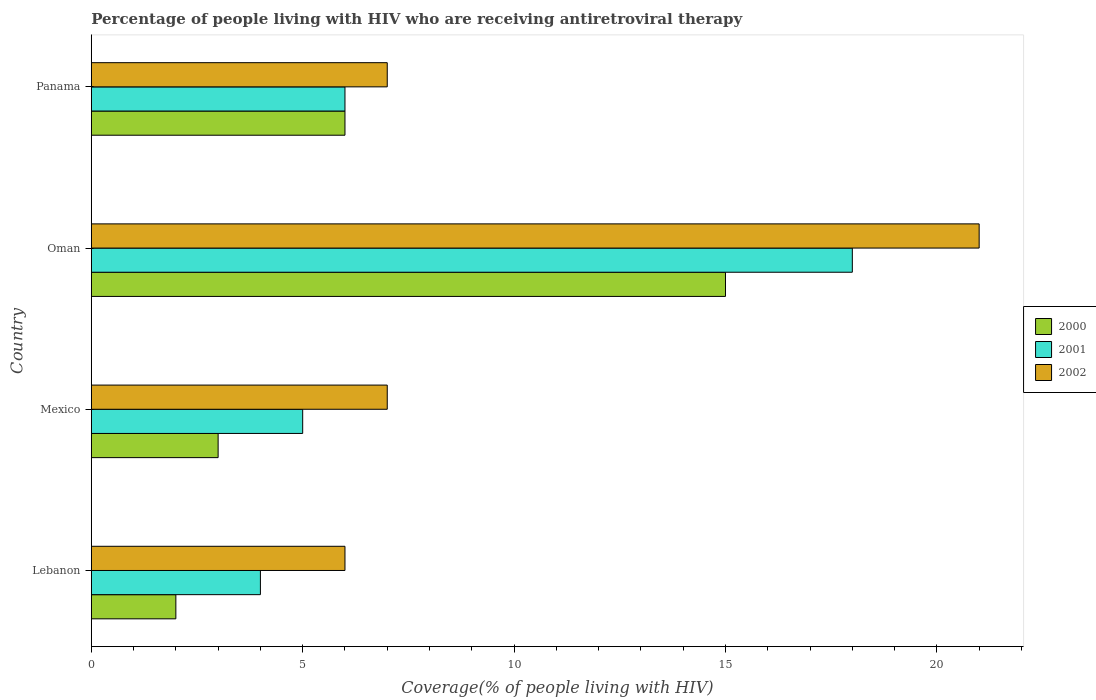How many different coloured bars are there?
Offer a terse response. 3. Are the number of bars per tick equal to the number of legend labels?
Your answer should be compact. Yes. Are the number of bars on each tick of the Y-axis equal?
Your answer should be compact. Yes. How many bars are there on the 3rd tick from the top?
Ensure brevity in your answer.  3. What is the label of the 3rd group of bars from the top?
Provide a succinct answer. Mexico. In how many cases, is the number of bars for a given country not equal to the number of legend labels?
Provide a succinct answer. 0. Across all countries, what is the minimum percentage of the HIV infected people who are receiving antiretroviral therapy in 2000?
Offer a very short reply. 2. In which country was the percentage of the HIV infected people who are receiving antiretroviral therapy in 2002 maximum?
Your answer should be compact. Oman. In which country was the percentage of the HIV infected people who are receiving antiretroviral therapy in 2001 minimum?
Offer a terse response. Lebanon. What is the average percentage of the HIV infected people who are receiving antiretroviral therapy in 2002 per country?
Keep it short and to the point. 10.25. In how many countries, is the percentage of the HIV infected people who are receiving antiretroviral therapy in 2000 greater than 5 %?
Make the answer very short. 2. What is the ratio of the percentage of the HIV infected people who are receiving antiretroviral therapy in 2002 in Lebanon to that in Panama?
Offer a terse response. 0.86. Is the percentage of the HIV infected people who are receiving antiretroviral therapy in 2002 in Lebanon less than that in Oman?
Give a very brief answer. Yes. Is the difference between the percentage of the HIV infected people who are receiving antiretroviral therapy in 2002 in Mexico and Oman greater than the difference between the percentage of the HIV infected people who are receiving antiretroviral therapy in 2001 in Mexico and Oman?
Provide a succinct answer. No. What is the difference between the highest and the second highest percentage of the HIV infected people who are receiving antiretroviral therapy in 2001?
Offer a very short reply. 12. What is the difference between the highest and the lowest percentage of the HIV infected people who are receiving antiretroviral therapy in 2002?
Your answer should be compact. 15. In how many countries, is the percentage of the HIV infected people who are receiving antiretroviral therapy in 2001 greater than the average percentage of the HIV infected people who are receiving antiretroviral therapy in 2001 taken over all countries?
Offer a very short reply. 1. Is the sum of the percentage of the HIV infected people who are receiving antiretroviral therapy in 2000 in Mexico and Panama greater than the maximum percentage of the HIV infected people who are receiving antiretroviral therapy in 2001 across all countries?
Offer a very short reply. No. What does the 1st bar from the bottom in Mexico represents?
Ensure brevity in your answer.  2000. Is it the case that in every country, the sum of the percentage of the HIV infected people who are receiving antiretroviral therapy in 2000 and percentage of the HIV infected people who are receiving antiretroviral therapy in 2002 is greater than the percentage of the HIV infected people who are receiving antiretroviral therapy in 2001?
Offer a terse response. Yes. Are all the bars in the graph horizontal?
Give a very brief answer. Yes. How many countries are there in the graph?
Keep it short and to the point. 4. What is the difference between two consecutive major ticks on the X-axis?
Provide a short and direct response. 5. Does the graph contain grids?
Offer a very short reply. No. How many legend labels are there?
Provide a short and direct response. 3. How are the legend labels stacked?
Provide a short and direct response. Vertical. What is the title of the graph?
Ensure brevity in your answer.  Percentage of people living with HIV who are receiving antiretroviral therapy. Does "1962" appear as one of the legend labels in the graph?
Ensure brevity in your answer.  No. What is the label or title of the X-axis?
Provide a short and direct response. Coverage(% of people living with HIV). What is the Coverage(% of people living with HIV) of 2000 in Lebanon?
Provide a succinct answer. 2. What is the Coverage(% of people living with HIV) of 2001 in Lebanon?
Keep it short and to the point. 4. What is the Coverage(% of people living with HIV) of 2002 in Lebanon?
Provide a short and direct response. 6. What is the Coverage(% of people living with HIV) in 2000 in Mexico?
Offer a terse response. 3. What is the Coverage(% of people living with HIV) of 2000 in Oman?
Provide a succinct answer. 15. What is the Coverage(% of people living with HIV) in 2002 in Oman?
Offer a very short reply. 21. What is the Coverage(% of people living with HIV) of 2000 in Panama?
Provide a succinct answer. 6. Across all countries, what is the maximum Coverage(% of people living with HIV) of 2000?
Provide a succinct answer. 15. Across all countries, what is the minimum Coverage(% of people living with HIV) in 2000?
Your answer should be compact. 2. Across all countries, what is the minimum Coverage(% of people living with HIV) of 2001?
Keep it short and to the point. 4. What is the total Coverage(% of people living with HIV) in 2000 in the graph?
Offer a very short reply. 26. What is the total Coverage(% of people living with HIV) in 2001 in the graph?
Offer a very short reply. 33. What is the total Coverage(% of people living with HIV) in 2002 in the graph?
Provide a succinct answer. 41. What is the difference between the Coverage(% of people living with HIV) of 2001 in Lebanon and that in Mexico?
Offer a terse response. -1. What is the difference between the Coverage(% of people living with HIV) of 2000 in Lebanon and that in Oman?
Offer a terse response. -13. What is the difference between the Coverage(% of people living with HIV) of 2001 in Lebanon and that in Oman?
Your response must be concise. -14. What is the difference between the Coverage(% of people living with HIV) in 2001 in Lebanon and that in Panama?
Provide a succinct answer. -2. What is the difference between the Coverage(% of people living with HIV) in 2002 in Lebanon and that in Panama?
Provide a short and direct response. -1. What is the difference between the Coverage(% of people living with HIV) in 2000 in Mexico and that in Panama?
Give a very brief answer. -3. What is the difference between the Coverage(% of people living with HIV) of 2001 in Mexico and that in Panama?
Ensure brevity in your answer.  -1. What is the difference between the Coverage(% of people living with HIV) of 2002 in Mexico and that in Panama?
Your response must be concise. 0. What is the difference between the Coverage(% of people living with HIV) in 2002 in Oman and that in Panama?
Offer a terse response. 14. What is the difference between the Coverage(% of people living with HIV) of 2001 in Lebanon and the Coverage(% of people living with HIV) of 2002 in Mexico?
Keep it short and to the point. -3. What is the difference between the Coverage(% of people living with HIV) of 2000 in Lebanon and the Coverage(% of people living with HIV) of 2002 in Oman?
Offer a terse response. -19. What is the difference between the Coverage(% of people living with HIV) in 2001 in Lebanon and the Coverage(% of people living with HIV) in 2002 in Panama?
Keep it short and to the point. -3. What is the difference between the Coverage(% of people living with HIV) in 2000 in Mexico and the Coverage(% of people living with HIV) in 2001 in Panama?
Ensure brevity in your answer.  -3. What is the difference between the Coverage(% of people living with HIV) of 2000 in Mexico and the Coverage(% of people living with HIV) of 2002 in Panama?
Give a very brief answer. -4. What is the difference between the Coverage(% of people living with HIV) of 2000 in Oman and the Coverage(% of people living with HIV) of 2001 in Panama?
Your answer should be very brief. 9. What is the difference between the Coverage(% of people living with HIV) of 2000 in Oman and the Coverage(% of people living with HIV) of 2002 in Panama?
Provide a short and direct response. 8. What is the average Coverage(% of people living with HIV) of 2000 per country?
Ensure brevity in your answer.  6.5. What is the average Coverage(% of people living with HIV) of 2001 per country?
Your answer should be compact. 8.25. What is the average Coverage(% of people living with HIV) of 2002 per country?
Give a very brief answer. 10.25. What is the difference between the Coverage(% of people living with HIV) of 2000 and Coverage(% of people living with HIV) of 2001 in Lebanon?
Ensure brevity in your answer.  -2. What is the difference between the Coverage(% of people living with HIV) in 2000 and Coverage(% of people living with HIV) in 2002 in Lebanon?
Offer a terse response. -4. What is the difference between the Coverage(% of people living with HIV) in 2001 and Coverage(% of people living with HIV) in 2002 in Lebanon?
Offer a terse response. -2. What is the difference between the Coverage(% of people living with HIV) of 2001 and Coverage(% of people living with HIV) of 2002 in Mexico?
Offer a terse response. -2. What is the difference between the Coverage(% of people living with HIV) in 2000 and Coverage(% of people living with HIV) in 2002 in Oman?
Keep it short and to the point. -6. What is the difference between the Coverage(% of people living with HIV) in 2000 and Coverage(% of people living with HIV) in 2002 in Panama?
Provide a short and direct response. -1. What is the difference between the Coverage(% of people living with HIV) of 2001 and Coverage(% of people living with HIV) of 2002 in Panama?
Give a very brief answer. -1. What is the ratio of the Coverage(% of people living with HIV) in 2002 in Lebanon to that in Mexico?
Offer a very short reply. 0.86. What is the ratio of the Coverage(% of people living with HIV) in 2000 in Lebanon to that in Oman?
Give a very brief answer. 0.13. What is the ratio of the Coverage(% of people living with HIV) of 2001 in Lebanon to that in Oman?
Keep it short and to the point. 0.22. What is the ratio of the Coverage(% of people living with HIV) of 2002 in Lebanon to that in Oman?
Provide a short and direct response. 0.29. What is the ratio of the Coverage(% of people living with HIV) in 2000 in Lebanon to that in Panama?
Provide a short and direct response. 0.33. What is the ratio of the Coverage(% of people living with HIV) in 2002 in Lebanon to that in Panama?
Provide a short and direct response. 0.86. What is the ratio of the Coverage(% of people living with HIV) in 2001 in Mexico to that in Oman?
Your answer should be compact. 0.28. What is the ratio of the Coverage(% of people living with HIV) of 2001 in Mexico to that in Panama?
Give a very brief answer. 0.83. What is the ratio of the Coverage(% of people living with HIV) in 2000 in Oman to that in Panama?
Your response must be concise. 2.5. What is the ratio of the Coverage(% of people living with HIV) of 2002 in Oman to that in Panama?
Your answer should be compact. 3. What is the difference between the highest and the second highest Coverage(% of people living with HIV) in 2001?
Your response must be concise. 12. What is the difference between the highest and the lowest Coverage(% of people living with HIV) in 2000?
Your response must be concise. 13. 